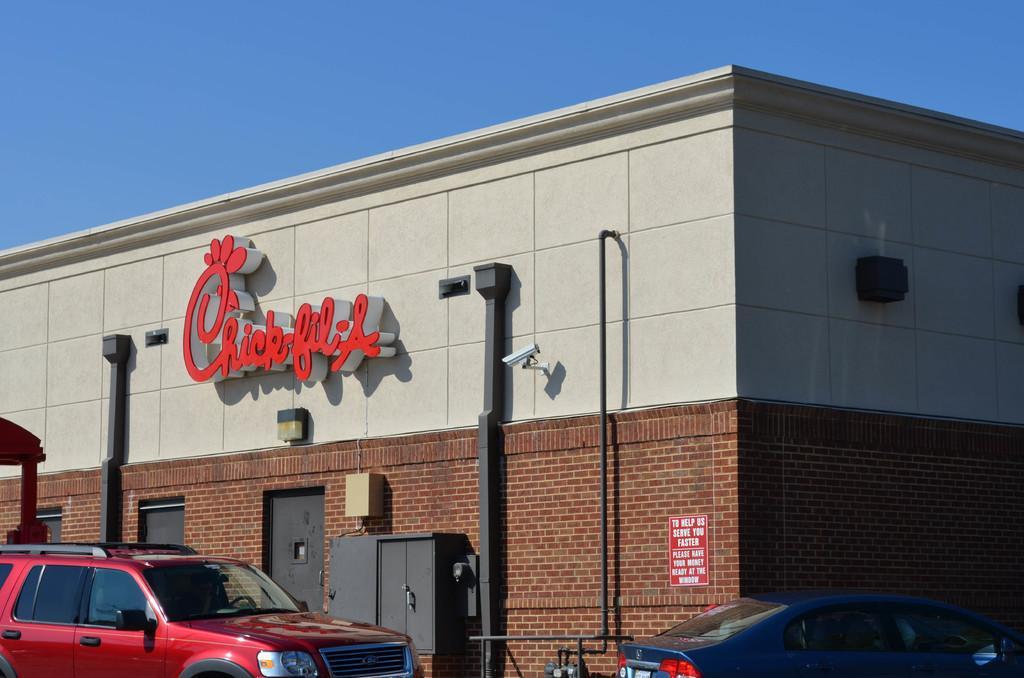Can you describe this image briefly? In this image in front there are cars. Behind the cars there is a building. In the background of the image there is sky. 